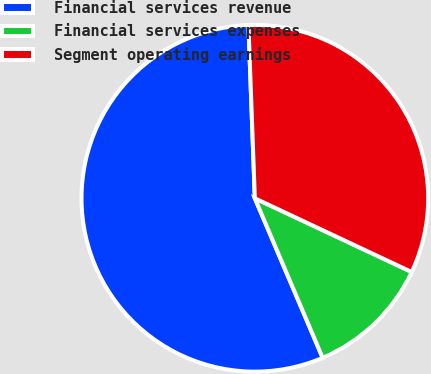<chart> <loc_0><loc_0><loc_500><loc_500><pie_chart><fcel>Financial services revenue<fcel>Financial services expenses<fcel>Segment operating earnings<nl><fcel>55.81%<fcel>11.61%<fcel>32.58%<nl></chart> 